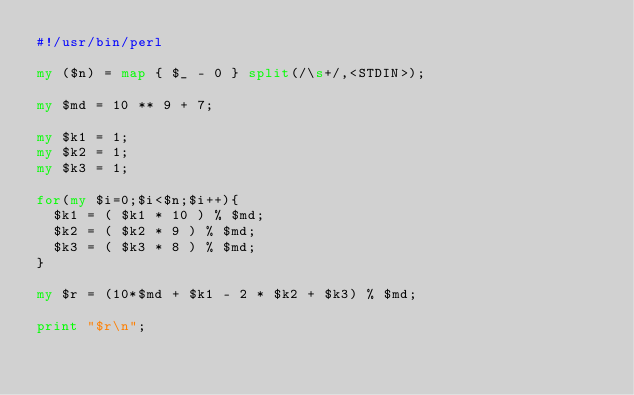Convert code to text. <code><loc_0><loc_0><loc_500><loc_500><_Perl_>#!/usr/bin/perl

my ($n) = map { $_ - 0 } split(/\s+/,<STDIN>);

my $md = 10 ** 9 + 7;

my $k1 = 1;
my $k2 = 1;
my $k3 = 1;

for(my $i=0;$i<$n;$i++){
  $k1 = ( $k1 * 10 ) % $md;
  $k2 = ( $k2 * 9 ) % $md;
  $k3 = ( $k3 * 8 ) % $md;
}

my $r = (10*$md + $k1 - 2 * $k2 + $k3) % $md;

print "$r\n";


</code> 